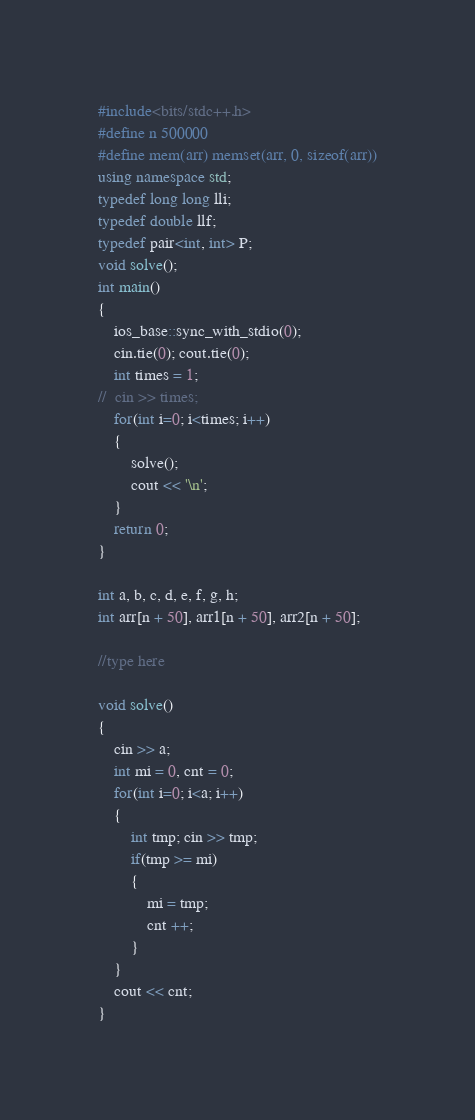<code> <loc_0><loc_0><loc_500><loc_500><_C++_>#include<bits/stdc++.h>
#define n 500000
#define mem(arr) memset(arr, 0, sizeof(arr))
using namespace std;
typedef long long lli;
typedef double llf;
typedef pair<int, int> P;
void solve();
int main()
{
	ios_base::sync_with_stdio(0);
	cin.tie(0); cout.tie(0);
	int times = 1;
//	cin >> times;
	for(int i=0; i<times; i++)
	{
		solve();
		cout << '\n';
	}
	return 0;
}

int a, b, c, d, e, f, g, h;
int arr[n + 50], arr1[n + 50], arr2[n + 50];

//type here

void solve()
{
	cin >> a;
	int mi = 0, cnt = 0;
	for(int i=0; i<a; i++)
	{
		int tmp; cin >> tmp;
		if(tmp >= mi)
		{
			mi = tmp;
			cnt ++;
		}
	}
	cout << cnt;
}</code> 